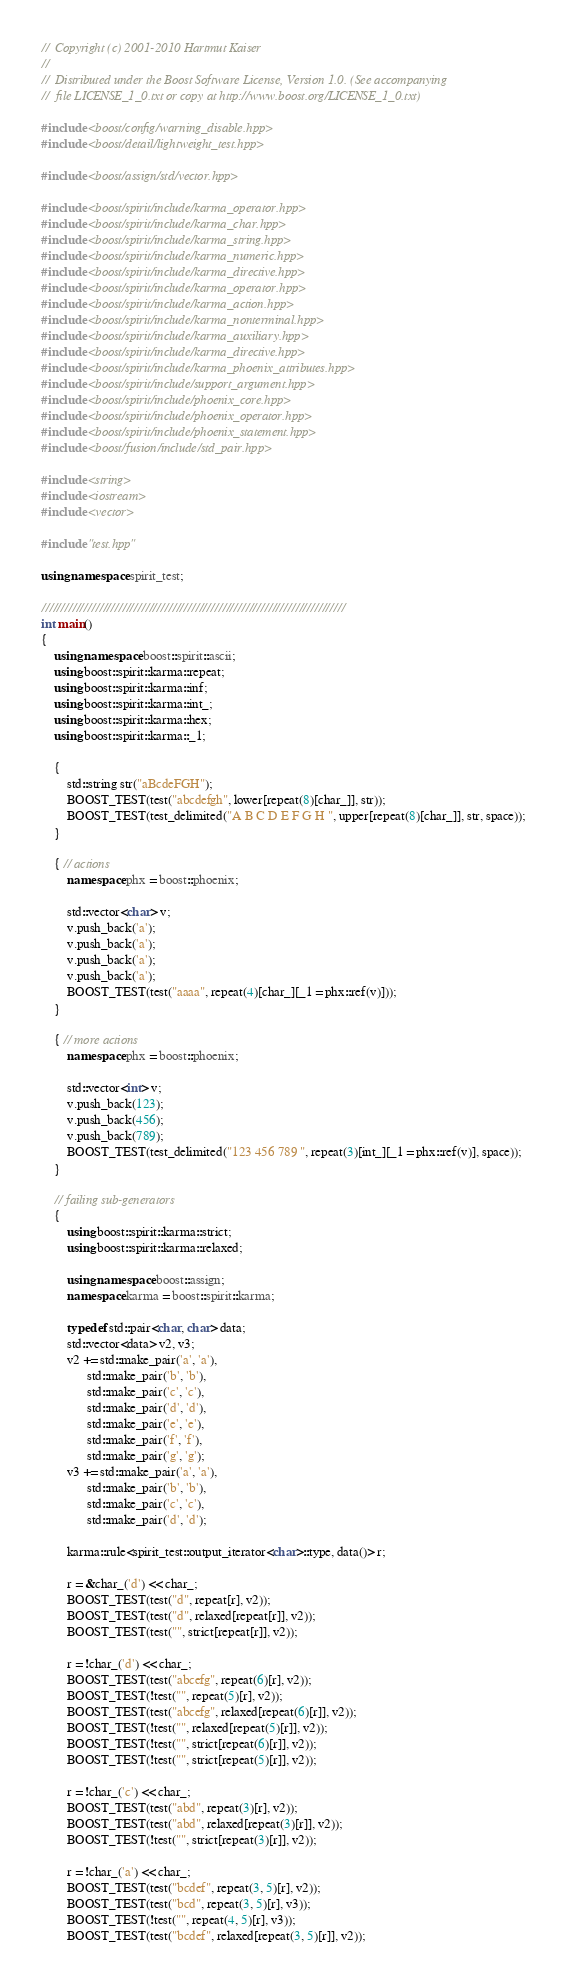<code> <loc_0><loc_0><loc_500><loc_500><_C++_>//  Copyright (c) 2001-2010 Hartmut Kaiser
// 
//  Distributed under the Boost Software License, Version 1.0. (See accompanying 
//  file LICENSE_1_0.txt or copy at http://www.boost.org/LICENSE_1_0.txt)

#include <boost/config/warning_disable.hpp>
#include <boost/detail/lightweight_test.hpp>

#include <boost/assign/std/vector.hpp>

#include <boost/spirit/include/karma_operator.hpp>
#include <boost/spirit/include/karma_char.hpp>
#include <boost/spirit/include/karma_string.hpp>
#include <boost/spirit/include/karma_numeric.hpp>
#include <boost/spirit/include/karma_directive.hpp>
#include <boost/spirit/include/karma_operator.hpp>
#include <boost/spirit/include/karma_action.hpp>
#include <boost/spirit/include/karma_nonterminal.hpp>
#include <boost/spirit/include/karma_auxiliary.hpp>
#include <boost/spirit/include/karma_directive.hpp>
#include <boost/spirit/include/karma_phoenix_attributes.hpp>
#include <boost/spirit/include/support_argument.hpp>
#include <boost/spirit/include/phoenix_core.hpp>
#include <boost/spirit/include/phoenix_operator.hpp>
#include <boost/spirit/include/phoenix_statement.hpp>
#include <boost/fusion/include/std_pair.hpp>

#include <string>
#include <iostream>
#include <vector>

#include "test.hpp"

using namespace spirit_test;

///////////////////////////////////////////////////////////////////////////////
int main()
{
    using namespace boost::spirit::ascii;
    using boost::spirit::karma::repeat;
    using boost::spirit::karma::inf;
    using boost::spirit::karma::int_;
    using boost::spirit::karma::hex;
    using boost::spirit::karma::_1;

    {
        std::string str("aBcdeFGH");
        BOOST_TEST(test("abcdefgh", lower[repeat(8)[char_]], str));
        BOOST_TEST(test_delimited("A B C D E F G H ", upper[repeat(8)[char_]], str, space));
    }

    { // actions
        namespace phx = boost::phoenix;

        std::vector<char> v;
        v.push_back('a');
        v.push_back('a');
        v.push_back('a');
        v.push_back('a');
        BOOST_TEST(test("aaaa", repeat(4)[char_][_1 = phx::ref(v)]));
    }

    { // more actions
        namespace phx = boost::phoenix;

        std::vector<int> v;
        v.push_back(123);
        v.push_back(456);
        v.push_back(789);
        BOOST_TEST(test_delimited("123 456 789 ", repeat(3)[int_][_1 = phx::ref(v)], space));
    }

    // failing sub-generators
    {
        using boost::spirit::karma::strict;
        using boost::spirit::karma::relaxed;

        using namespace boost::assign;
        namespace karma = boost::spirit::karma;

        typedef std::pair<char, char> data;
        std::vector<data> v2, v3;
        v2 += std::make_pair('a', 'a'),
              std::make_pair('b', 'b'),
              std::make_pair('c', 'c'),
              std::make_pair('d', 'd'),
              std::make_pair('e', 'e'),
              std::make_pair('f', 'f'),
              std::make_pair('g', 'g');
        v3 += std::make_pair('a', 'a'),
              std::make_pair('b', 'b'),
              std::make_pair('c', 'c'),
              std::make_pair('d', 'd');

        karma::rule<spirit_test::output_iterator<char>::type, data()> r;

        r = &char_('d') << char_;
        BOOST_TEST(test("d", repeat[r], v2));
        BOOST_TEST(test("d", relaxed[repeat[r]], v2));
        BOOST_TEST(test("", strict[repeat[r]], v2));

        r = !char_('d') << char_;
        BOOST_TEST(test("abcefg", repeat(6)[r], v2));
        BOOST_TEST(!test("", repeat(5)[r], v2));
        BOOST_TEST(test("abcefg", relaxed[repeat(6)[r]], v2));
        BOOST_TEST(!test("", relaxed[repeat(5)[r]], v2));
        BOOST_TEST(!test("", strict[repeat(6)[r]], v2));
        BOOST_TEST(!test("", strict[repeat(5)[r]], v2));

        r = !char_('c') << char_;
        BOOST_TEST(test("abd", repeat(3)[r], v2));
        BOOST_TEST(test("abd", relaxed[repeat(3)[r]], v2));
        BOOST_TEST(!test("", strict[repeat(3)[r]], v2));

        r = !char_('a') << char_;
        BOOST_TEST(test("bcdef", repeat(3, 5)[r], v2));
        BOOST_TEST(test("bcd", repeat(3, 5)[r], v3));
        BOOST_TEST(!test("", repeat(4, 5)[r], v3));
        BOOST_TEST(test("bcdef", relaxed[repeat(3, 5)[r]], v2));</code> 